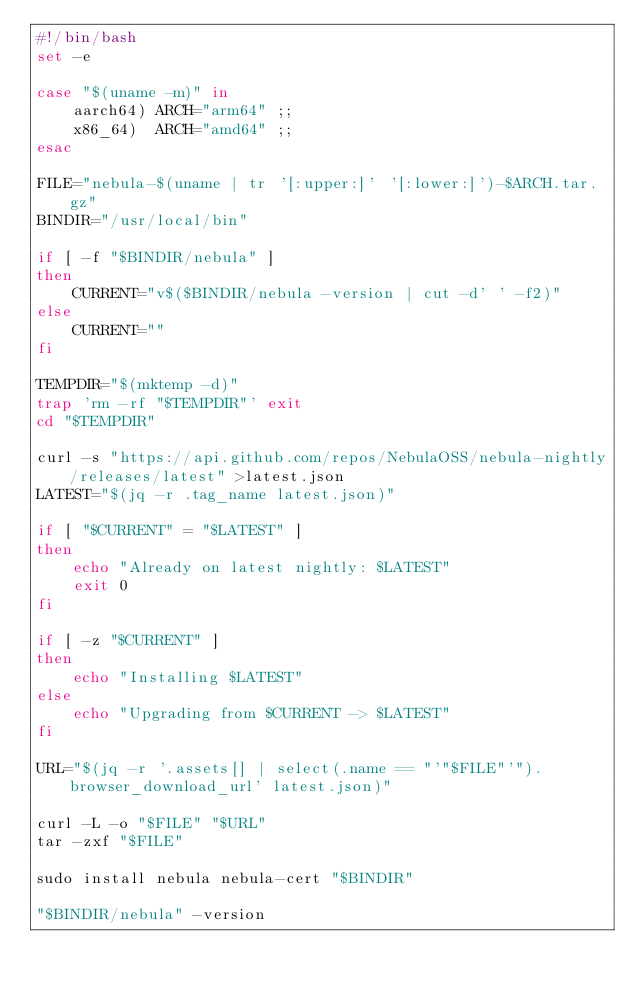<code> <loc_0><loc_0><loc_500><loc_500><_Bash_>#!/bin/bash
set -e

case "$(uname -m)" in
    aarch64) ARCH="arm64" ;;
    x86_64)  ARCH="amd64" ;;
esac

FILE="nebula-$(uname | tr '[:upper:]' '[:lower:]')-$ARCH.tar.gz"
BINDIR="/usr/local/bin"

if [ -f "$BINDIR/nebula" ]
then
    CURRENT="v$($BINDIR/nebula -version | cut -d' ' -f2)"
else
    CURRENT=""
fi

TEMPDIR="$(mktemp -d)"
trap 'rm -rf "$TEMPDIR"' exit
cd "$TEMPDIR"

curl -s "https://api.github.com/repos/NebulaOSS/nebula-nightly/releases/latest" >latest.json
LATEST="$(jq -r .tag_name latest.json)"

if [ "$CURRENT" = "$LATEST" ]
then
    echo "Already on latest nightly: $LATEST"
    exit 0
fi

if [ -z "$CURRENT" ]
then
    echo "Installing $LATEST"
else
    echo "Upgrading from $CURRENT -> $LATEST"
fi

URL="$(jq -r '.assets[] | select(.name == "'"$FILE"'").browser_download_url' latest.json)"

curl -L -o "$FILE" "$URL"
tar -zxf "$FILE"

sudo install nebula nebula-cert "$BINDIR"

"$BINDIR/nebula" -version
</code> 